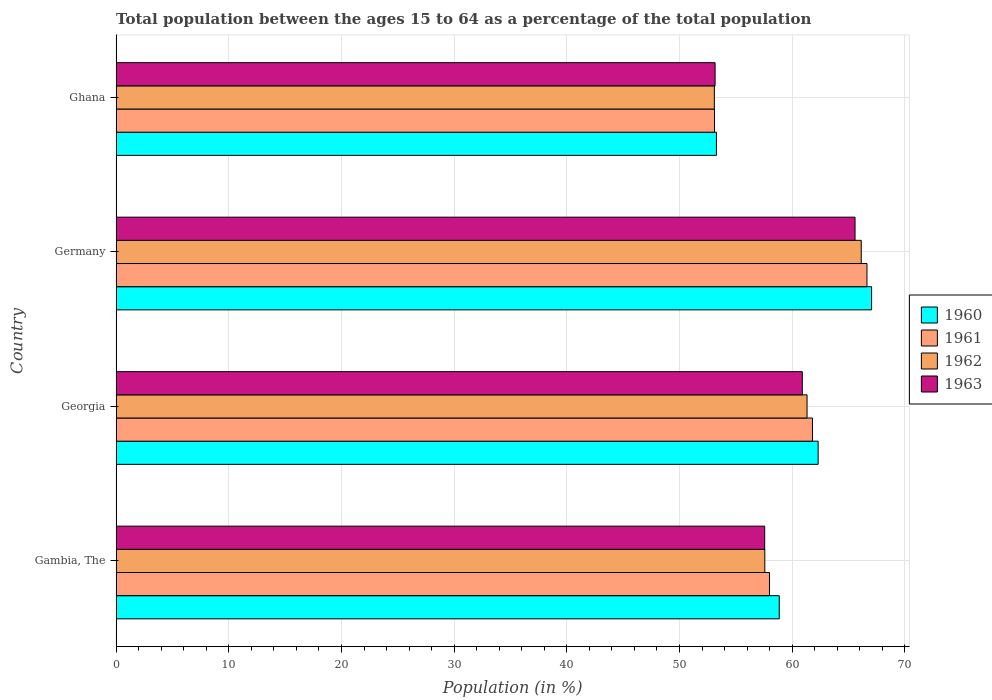How many different coloured bars are there?
Offer a terse response. 4. Are the number of bars per tick equal to the number of legend labels?
Your response must be concise. Yes. How many bars are there on the 1st tick from the top?
Keep it short and to the point. 4. In how many cases, is the number of bars for a given country not equal to the number of legend labels?
Your response must be concise. 0. What is the percentage of the population ages 15 to 64 in 1963 in Georgia?
Keep it short and to the point. 60.9. Across all countries, what is the maximum percentage of the population ages 15 to 64 in 1962?
Provide a short and direct response. 66.13. Across all countries, what is the minimum percentage of the population ages 15 to 64 in 1961?
Your response must be concise. 53.11. In which country was the percentage of the population ages 15 to 64 in 1963 minimum?
Offer a terse response. Ghana. What is the total percentage of the population ages 15 to 64 in 1961 in the graph?
Ensure brevity in your answer.  239.54. What is the difference between the percentage of the population ages 15 to 64 in 1961 in Gambia, The and that in Germany?
Offer a very short reply. -8.65. What is the difference between the percentage of the population ages 15 to 64 in 1963 in Georgia and the percentage of the population ages 15 to 64 in 1960 in Germany?
Your answer should be compact. -6.15. What is the average percentage of the population ages 15 to 64 in 1962 per country?
Give a very brief answer. 59.53. What is the difference between the percentage of the population ages 15 to 64 in 1960 and percentage of the population ages 15 to 64 in 1961 in Gambia, The?
Your answer should be very brief. 0.87. What is the ratio of the percentage of the population ages 15 to 64 in 1961 in Germany to that in Ghana?
Ensure brevity in your answer.  1.25. Is the percentage of the population ages 15 to 64 in 1961 in Gambia, The less than that in Georgia?
Your answer should be compact. Yes. What is the difference between the highest and the second highest percentage of the population ages 15 to 64 in 1963?
Ensure brevity in your answer.  4.68. What is the difference between the highest and the lowest percentage of the population ages 15 to 64 in 1961?
Make the answer very short. 13.53. What does the 3rd bar from the top in Ghana represents?
Provide a short and direct response. 1961. Is it the case that in every country, the sum of the percentage of the population ages 15 to 64 in 1962 and percentage of the population ages 15 to 64 in 1961 is greater than the percentage of the population ages 15 to 64 in 1960?
Provide a succinct answer. Yes. Are all the bars in the graph horizontal?
Offer a very short reply. Yes. What is the difference between two consecutive major ticks on the X-axis?
Provide a succinct answer. 10. Are the values on the major ticks of X-axis written in scientific E-notation?
Make the answer very short. No. Does the graph contain any zero values?
Offer a very short reply. No. Where does the legend appear in the graph?
Your answer should be compact. Center right. How are the legend labels stacked?
Provide a succinct answer. Vertical. What is the title of the graph?
Keep it short and to the point. Total population between the ages 15 to 64 as a percentage of the total population. Does "1986" appear as one of the legend labels in the graph?
Make the answer very short. No. What is the Population (in %) of 1960 in Gambia, The?
Provide a succinct answer. 58.86. What is the Population (in %) of 1961 in Gambia, The?
Ensure brevity in your answer.  57.99. What is the Population (in %) of 1962 in Gambia, The?
Make the answer very short. 57.57. What is the Population (in %) in 1963 in Gambia, The?
Give a very brief answer. 57.56. What is the Population (in %) of 1960 in Georgia?
Ensure brevity in your answer.  62.31. What is the Population (in %) of 1961 in Georgia?
Make the answer very short. 61.8. What is the Population (in %) of 1962 in Georgia?
Provide a short and direct response. 61.32. What is the Population (in %) in 1963 in Georgia?
Make the answer very short. 60.9. What is the Population (in %) in 1960 in Germany?
Ensure brevity in your answer.  67.05. What is the Population (in %) of 1961 in Germany?
Offer a very short reply. 66.64. What is the Population (in %) in 1962 in Germany?
Your answer should be compact. 66.13. What is the Population (in %) in 1963 in Germany?
Make the answer very short. 65.58. What is the Population (in %) of 1960 in Ghana?
Offer a terse response. 53.28. What is the Population (in %) in 1961 in Ghana?
Provide a short and direct response. 53.11. What is the Population (in %) of 1962 in Ghana?
Your response must be concise. 53.1. What is the Population (in %) of 1963 in Ghana?
Offer a terse response. 53.16. Across all countries, what is the maximum Population (in %) of 1960?
Offer a very short reply. 67.05. Across all countries, what is the maximum Population (in %) in 1961?
Ensure brevity in your answer.  66.64. Across all countries, what is the maximum Population (in %) in 1962?
Your answer should be very brief. 66.13. Across all countries, what is the maximum Population (in %) in 1963?
Provide a succinct answer. 65.58. Across all countries, what is the minimum Population (in %) of 1960?
Offer a very short reply. 53.28. Across all countries, what is the minimum Population (in %) in 1961?
Give a very brief answer. 53.11. Across all countries, what is the minimum Population (in %) in 1962?
Offer a terse response. 53.1. Across all countries, what is the minimum Population (in %) in 1963?
Your answer should be compact. 53.16. What is the total Population (in %) of 1960 in the graph?
Make the answer very short. 241.49. What is the total Population (in %) of 1961 in the graph?
Keep it short and to the point. 239.54. What is the total Population (in %) in 1962 in the graph?
Your answer should be very brief. 238.13. What is the total Population (in %) in 1963 in the graph?
Offer a very short reply. 237.21. What is the difference between the Population (in %) of 1960 in Gambia, The and that in Georgia?
Give a very brief answer. -3.45. What is the difference between the Population (in %) in 1961 in Gambia, The and that in Georgia?
Your response must be concise. -3.82. What is the difference between the Population (in %) in 1962 in Gambia, The and that in Georgia?
Provide a succinct answer. -3.75. What is the difference between the Population (in %) in 1963 in Gambia, The and that in Georgia?
Offer a terse response. -3.34. What is the difference between the Population (in %) in 1960 in Gambia, The and that in Germany?
Offer a terse response. -8.2. What is the difference between the Population (in %) of 1961 in Gambia, The and that in Germany?
Your response must be concise. -8.65. What is the difference between the Population (in %) of 1962 in Gambia, The and that in Germany?
Provide a succinct answer. -8.56. What is the difference between the Population (in %) of 1963 in Gambia, The and that in Germany?
Give a very brief answer. -8.02. What is the difference between the Population (in %) of 1960 in Gambia, The and that in Ghana?
Offer a very short reply. 5.58. What is the difference between the Population (in %) of 1961 in Gambia, The and that in Ghana?
Ensure brevity in your answer.  4.88. What is the difference between the Population (in %) in 1962 in Gambia, The and that in Ghana?
Make the answer very short. 4.48. What is the difference between the Population (in %) of 1963 in Gambia, The and that in Ghana?
Your answer should be compact. 4.4. What is the difference between the Population (in %) in 1960 in Georgia and that in Germany?
Make the answer very short. -4.74. What is the difference between the Population (in %) of 1961 in Georgia and that in Germany?
Offer a very short reply. -4.84. What is the difference between the Population (in %) in 1962 in Georgia and that in Germany?
Give a very brief answer. -4.81. What is the difference between the Population (in %) in 1963 in Georgia and that in Germany?
Your answer should be very brief. -4.68. What is the difference between the Population (in %) of 1960 in Georgia and that in Ghana?
Offer a terse response. 9.03. What is the difference between the Population (in %) in 1961 in Georgia and that in Ghana?
Provide a short and direct response. 8.69. What is the difference between the Population (in %) of 1962 in Georgia and that in Ghana?
Make the answer very short. 8.23. What is the difference between the Population (in %) in 1963 in Georgia and that in Ghana?
Keep it short and to the point. 7.74. What is the difference between the Population (in %) of 1960 in Germany and that in Ghana?
Make the answer very short. 13.77. What is the difference between the Population (in %) of 1961 in Germany and that in Ghana?
Your response must be concise. 13.53. What is the difference between the Population (in %) of 1962 in Germany and that in Ghana?
Offer a very short reply. 13.04. What is the difference between the Population (in %) of 1963 in Germany and that in Ghana?
Your response must be concise. 12.42. What is the difference between the Population (in %) of 1960 in Gambia, The and the Population (in %) of 1961 in Georgia?
Ensure brevity in your answer.  -2.95. What is the difference between the Population (in %) in 1960 in Gambia, The and the Population (in %) in 1962 in Georgia?
Provide a succinct answer. -2.47. What is the difference between the Population (in %) of 1960 in Gambia, The and the Population (in %) of 1963 in Georgia?
Provide a succinct answer. -2.05. What is the difference between the Population (in %) of 1961 in Gambia, The and the Population (in %) of 1962 in Georgia?
Offer a very short reply. -3.33. What is the difference between the Population (in %) of 1961 in Gambia, The and the Population (in %) of 1963 in Georgia?
Offer a very short reply. -2.91. What is the difference between the Population (in %) in 1962 in Gambia, The and the Population (in %) in 1963 in Georgia?
Make the answer very short. -3.33. What is the difference between the Population (in %) of 1960 in Gambia, The and the Population (in %) of 1961 in Germany?
Give a very brief answer. -7.78. What is the difference between the Population (in %) in 1960 in Gambia, The and the Population (in %) in 1962 in Germany?
Your answer should be compact. -7.28. What is the difference between the Population (in %) in 1960 in Gambia, The and the Population (in %) in 1963 in Germany?
Provide a succinct answer. -6.73. What is the difference between the Population (in %) in 1961 in Gambia, The and the Population (in %) in 1962 in Germany?
Offer a terse response. -8.15. What is the difference between the Population (in %) of 1961 in Gambia, The and the Population (in %) of 1963 in Germany?
Offer a terse response. -7.59. What is the difference between the Population (in %) of 1962 in Gambia, The and the Population (in %) of 1963 in Germany?
Offer a terse response. -8.01. What is the difference between the Population (in %) in 1960 in Gambia, The and the Population (in %) in 1961 in Ghana?
Give a very brief answer. 5.75. What is the difference between the Population (in %) of 1960 in Gambia, The and the Population (in %) of 1962 in Ghana?
Give a very brief answer. 5.76. What is the difference between the Population (in %) in 1960 in Gambia, The and the Population (in %) in 1963 in Ghana?
Make the answer very short. 5.69. What is the difference between the Population (in %) of 1961 in Gambia, The and the Population (in %) of 1962 in Ghana?
Make the answer very short. 4.89. What is the difference between the Population (in %) of 1961 in Gambia, The and the Population (in %) of 1963 in Ghana?
Your response must be concise. 4.83. What is the difference between the Population (in %) of 1962 in Gambia, The and the Population (in %) of 1963 in Ghana?
Your response must be concise. 4.41. What is the difference between the Population (in %) of 1960 in Georgia and the Population (in %) of 1961 in Germany?
Provide a succinct answer. -4.33. What is the difference between the Population (in %) of 1960 in Georgia and the Population (in %) of 1962 in Germany?
Provide a succinct answer. -3.83. What is the difference between the Population (in %) in 1960 in Georgia and the Population (in %) in 1963 in Germany?
Provide a short and direct response. -3.28. What is the difference between the Population (in %) of 1961 in Georgia and the Population (in %) of 1962 in Germany?
Your answer should be compact. -4.33. What is the difference between the Population (in %) in 1961 in Georgia and the Population (in %) in 1963 in Germany?
Offer a very short reply. -3.78. What is the difference between the Population (in %) in 1962 in Georgia and the Population (in %) in 1963 in Germany?
Make the answer very short. -4.26. What is the difference between the Population (in %) in 1960 in Georgia and the Population (in %) in 1961 in Ghana?
Keep it short and to the point. 9.2. What is the difference between the Population (in %) of 1960 in Georgia and the Population (in %) of 1962 in Ghana?
Give a very brief answer. 9.21. What is the difference between the Population (in %) of 1960 in Georgia and the Population (in %) of 1963 in Ghana?
Offer a very short reply. 9.15. What is the difference between the Population (in %) of 1961 in Georgia and the Population (in %) of 1962 in Ghana?
Offer a terse response. 8.71. What is the difference between the Population (in %) of 1961 in Georgia and the Population (in %) of 1963 in Ghana?
Give a very brief answer. 8.64. What is the difference between the Population (in %) of 1962 in Georgia and the Population (in %) of 1963 in Ghana?
Your answer should be compact. 8.16. What is the difference between the Population (in %) of 1960 in Germany and the Population (in %) of 1961 in Ghana?
Give a very brief answer. 13.94. What is the difference between the Population (in %) of 1960 in Germany and the Population (in %) of 1962 in Ghana?
Give a very brief answer. 13.95. What is the difference between the Population (in %) of 1960 in Germany and the Population (in %) of 1963 in Ghana?
Give a very brief answer. 13.89. What is the difference between the Population (in %) in 1961 in Germany and the Population (in %) in 1962 in Ghana?
Offer a terse response. 13.54. What is the difference between the Population (in %) of 1961 in Germany and the Population (in %) of 1963 in Ghana?
Offer a terse response. 13.48. What is the difference between the Population (in %) in 1962 in Germany and the Population (in %) in 1963 in Ghana?
Your answer should be very brief. 12.97. What is the average Population (in %) of 1960 per country?
Your answer should be compact. 60.37. What is the average Population (in %) of 1961 per country?
Your answer should be compact. 59.88. What is the average Population (in %) in 1962 per country?
Your answer should be very brief. 59.53. What is the average Population (in %) of 1963 per country?
Your response must be concise. 59.3. What is the difference between the Population (in %) of 1960 and Population (in %) of 1961 in Gambia, The?
Your answer should be compact. 0.87. What is the difference between the Population (in %) of 1960 and Population (in %) of 1962 in Gambia, The?
Make the answer very short. 1.28. What is the difference between the Population (in %) in 1960 and Population (in %) in 1963 in Gambia, The?
Offer a very short reply. 1.29. What is the difference between the Population (in %) in 1961 and Population (in %) in 1962 in Gambia, The?
Provide a short and direct response. 0.41. What is the difference between the Population (in %) in 1961 and Population (in %) in 1963 in Gambia, The?
Offer a terse response. 0.43. What is the difference between the Population (in %) of 1962 and Population (in %) of 1963 in Gambia, The?
Ensure brevity in your answer.  0.01. What is the difference between the Population (in %) of 1960 and Population (in %) of 1961 in Georgia?
Make the answer very short. 0.5. What is the difference between the Population (in %) in 1960 and Population (in %) in 1962 in Georgia?
Provide a short and direct response. 0.98. What is the difference between the Population (in %) of 1960 and Population (in %) of 1963 in Georgia?
Provide a succinct answer. 1.4. What is the difference between the Population (in %) of 1961 and Population (in %) of 1962 in Georgia?
Your response must be concise. 0.48. What is the difference between the Population (in %) of 1961 and Population (in %) of 1963 in Georgia?
Offer a terse response. 0.9. What is the difference between the Population (in %) in 1962 and Population (in %) in 1963 in Georgia?
Give a very brief answer. 0.42. What is the difference between the Population (in %) in 1960 and Population (in %) in 1961 in Germany?
Offer a very short reply. 0.41. What is the difference between the Population (in %) of 1960 and Population (in %) of 1962 in Germany?
Ensure brevity in your answer.  0.92. What is the difference between the Population (in %) of 1960 and Population (in %) of 1963 in Germany?
Ensure brevity in your answer.  1.47. What is the difference between the Population (in %) in 1961 and Population (in %) in 1962 in Germany?
Make the answer very short. 0.51. What is the difference between the Population (in %) in 1961 and Population (in %) in 1963 in Germany?
Offer a very short reply. 1.06. What is the difference between the Population (in %) in 1962 and Population (in %) in 1963 in Germany?
Provide a short and direct response. 0.55. What is the difference between the Population (in %) in 1960 and Population (in %) in 1961 in Ghana?
Provide a short and direct response. 0.17. What is the difference between the Population (in %) in 1960 and Population (in %) in 1962 in Ghana?
Your answer should be compact. 0.18. What is the difference between the Population (in %) in 1960 and Population (in %) in 1963 in Ghana?
Keep it short and to the point. 0.12. What is the difference between the Population (in %) of 1961 and Population (in %) of 1962 in Ghana?
Ensure brevity in your answer.  0.01. What is the difference between the Population (in %) in 1961 and Population (in %) in 1963 in Ghana?
Give a very brief answer. -0.05. What is the difference between the Population (in %) of 1962 and Population (in %) of 1963 in Ghana?
Ensure brevity in your answer.  -0.06. What is the ratio of the Population (in %) in 1960 in Gambia, The to that in Georgia?
Offer a terse response. 0.94. What is the ratio of the Population (in %) in 1961 in Gambia, The to that in Georgia?
Give a very brief answer. 0.94. What is the ratio of the Population (in %) in 1962 in Gambia, The to that in Georgia?
Give a very brief answer. 0.94. What is the ratio of the Population (in %) of 1963 in Gambia, The to that in Georgia?
Your answer should be very brief. 0.95. What is the ratio of the Population (in %) of 1960 in Gambia, The to that in Germany?
Make the answer very short. 0.88. What is the ratio of the Population (in %) of 1961 in Gambia, The to that in Germany?
Keep it short and to the point. 0.87. What is the ratio of the Population (in %) in 1962 in Gambia, The to that in Germany?
Make the answer very short. 0.87. What is the ratio of the Population (in %) of 1963 in Gambia, The to that in Germany?
Keep it short and to the point. 0.88. What is the ratio of the Population (in %) in 1960 in Gambia, The to that in Ghana?
Your answer should be compact. 1.1. What is the ratio of the Population (in %) of 1961 in Gambia, The to that in Ghana?
Give a very brief answer. 1.09. What is the ratio of the Population (in %) of 1962 in Gambia, The to that in Ghana?
Give a very brief answer. 1.08. What is the ratio of the Population (in %) in 1963 in Gambia, The to that in Ghana?
Ensure brevity in your answer.  1.08. What is the ratio of the Population (in %) of 1960 in Georgia to that in Germany?
Your answer should be compact. 0.93. What is the ratio of the Population (in %) of 1961 in Georgia to that in Germany?
Make the answer very short. 0.93. What is the ratio of the Population (in %) in 1962 in Georgia to that in Germany?
Offer a terse response. 0.93. What is the ratio of the Population (in %) in 1963 in Georgia to that in Germany?
Make the answer very short. 0.93. What is the ratio of the Population (in %) of 1960 in Georgia to that in Ghana?
Your response must be concise. 1.17. What is the ratio of the Population (in %) of 1961 in Georgia to that in Ghana?
Offer a very short reply. 1.16. What is the ratio of the Population (in %) in 1962 in Georgia to that in Ghana?
Your answer should be compact. 1.15. What is the ratio of the Population (in %) of 1963 in Georgia to that in Ghana?
Provide a succinct answer. 1.15. What is the ratio of the Population (in %) in 1960 in Germany to that in Ghana?
Provide a short and direct response. 1.26. What is the ratio of the Population (in %) in 1961 in Germany to that in Ghana?
Your response must be concise. 1.25. What is the ratio of the Population (in %) of 1962 in Germany to that in Ghana?
Provide a succinct answer. 1.25. What is the ratio of the Population (in %) of 1963 in Germany to that in Ghana?
Provide a short and direct response. 1.23. What is the difference between the highest and the second highest Population (in %) of 1960?
Keep it short and to the point. 4.74. What is the difference between the highest and the second highest Population (in %) of 1961?
Keep it short and to the point. 4.84. What is the difference between the highest and the second highest Population (in %) in 1962?
Give a very brief answer. 4.81. What is the difference between the highest and the second highest Population (in %) of 1963?
Keep it short and to the point. 4.68. What is the difference between the highest and the lowest Population (in %) of 1960?
Give a very brief answer. 13.77. What is the difference between the highest and the lowest Population (in %) of 1961?
Your answer should be very brief. 13.53. What is the difference between the highest and the lowest Population (in %) in 1962?
Provide a succinct answer. 13.04. What is the difference between the highest and the lowest Population (in %) in 1963?
Offer a very short reply. 12.42. 